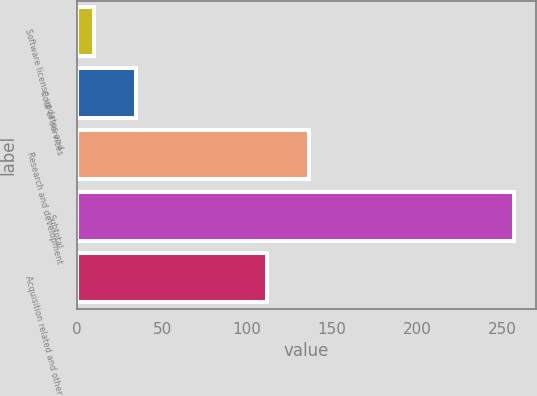Convert chart to OTSL. <chart><loc_0><loc_0><loc_500><loc_500><bar_chart><fcel>Software license updates and<fcel>Cost of services<fcel>Research and development<fcel>Subtotal<fcel>Acquisition related and other<nl><fcel>10<fcel>34.7<fcel>136.7<fcel>257<fcel>112<nl></chart> 